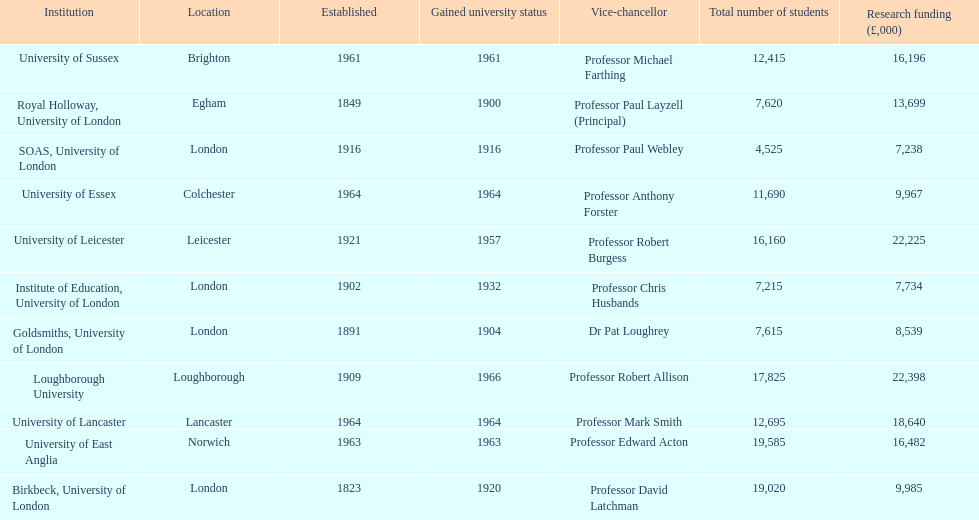Which institution has the most research funding? Loughborough University. 